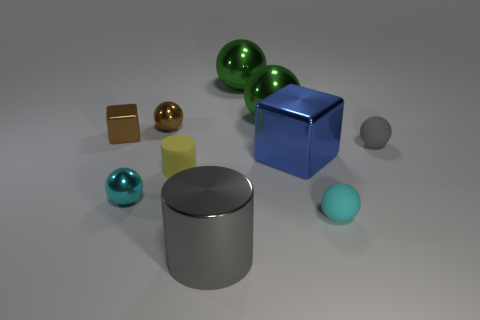Is the shape of the tiny yellow object the same as the big gray object? yes 